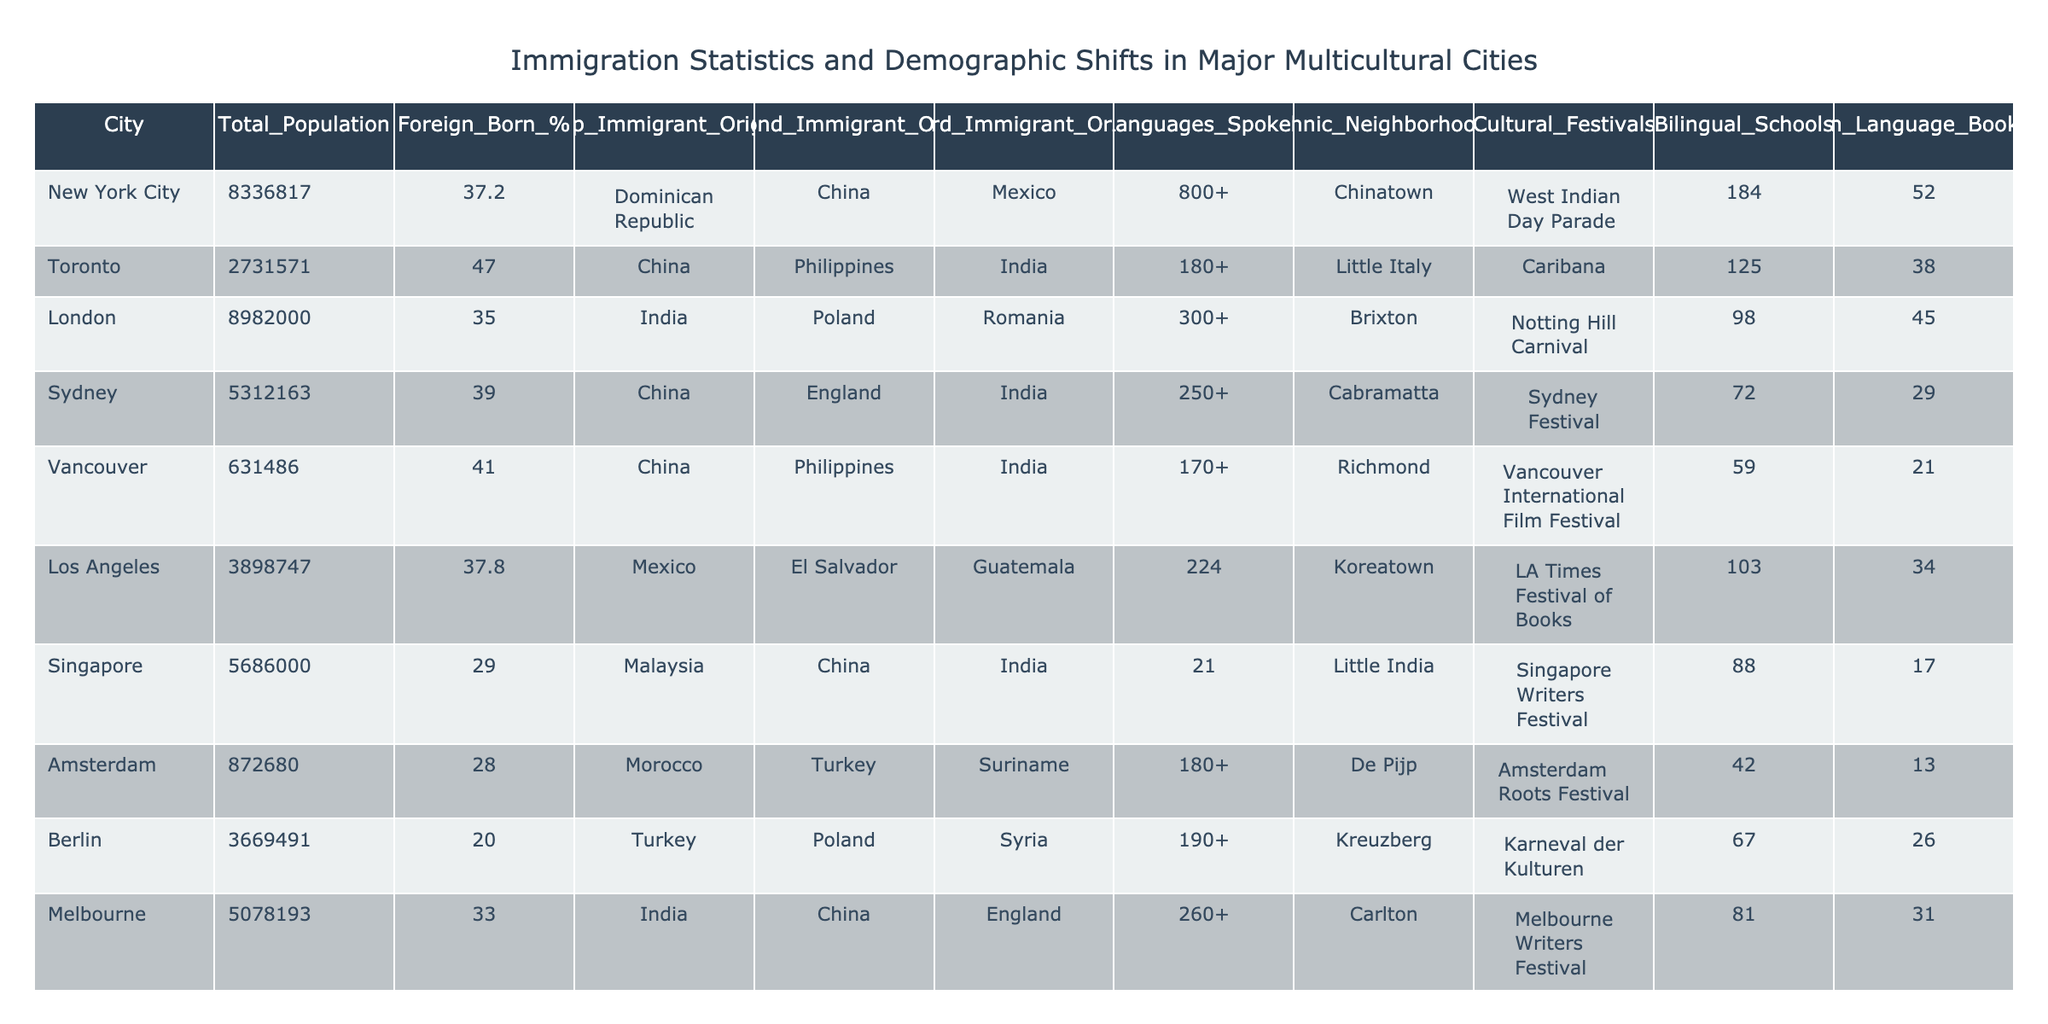What city has the highest percentage of foreign-born population? By comparing the "Foreign_Born_%" column, Toronto has the highest percentage at 47.0%.
Answer: Toronto What are the top three immigrant origins for New York City? From the "Top_Immigrant_Origin," "Second_Immigrant_Origin," and "Third_Immigrant_Origin" columns, the top three immigrant origins are Dominican Republic, China, and Mexico.
Answer: Dominican Republic, China, Mexico Is there an ethnic neighborhood named "Little India" in Los Angeles? The table lists "Koreatown" as the ethnic neighborhood for Los Angeles, not "Little India," so this statement is false.
Answer: No Which city has the least number of bilingual schools? By checking the "Bilingual_Schools" column, Amsterdam has the least with 13 bilingual schools.
Answer: Amsterdam What is the average percentage of foreign-born populations across all listed cities? Adding the foreign-born percentages (37.2 + 47.0 + 35.0 + 39.0 + 41.0 + 37.8 + 29.0 + 28.0 + 20.0 + 33.0) gives  373.0% for 10 cities. Dividing by 10 gives an average of 37.3%.
Answer: 37.3% What cultural festival is unique to Toronto? Toronto hosts "Caribana," which is not listed for any other city in the table.
Answer: Caribana Which city has the most languages spoken, and how many are there? Sydney lists 250+ languages spoken, which is the highest in the "Languages_Spoken" column.
Answer: 250+ If we combine the foreign language bookstores in Sydney and Melbourne, how many are there in total? From the "Foreign_Language_Bookstores" column, Sydney has 29 and Melbourne has 31. Adding them gives a total of 60 bookstores.
Answer: 60 Which city has the highest population, and what is that number? By reviewing the "Total_Population" column, New York City has the highest population at 8,336,817.
Answer: 8,336,817 Is the majority of the population in Berlin foreign-born? With a foreign-born percentage of 20.0%, less than a majority, this statement is false.
Answer: No 